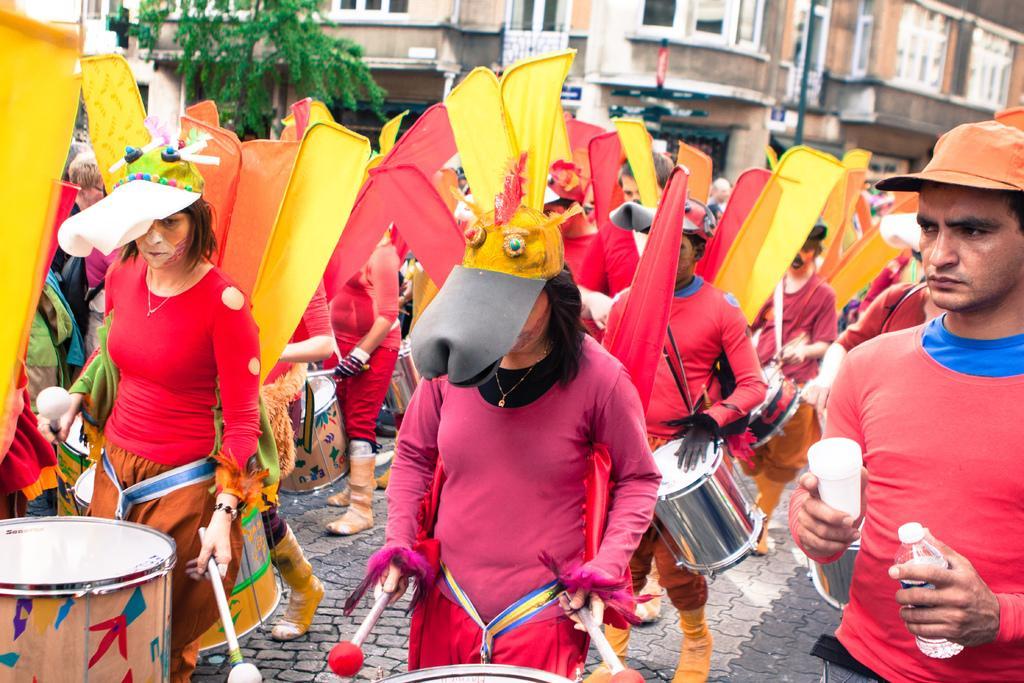Could you give a brief overview of what you see in this image? In this picture we can see group of people standing on road and playing drums they wore colorful costumes and here right side man holding glass and bottle in his hands and in background we can see building with windows, trees, banner. 